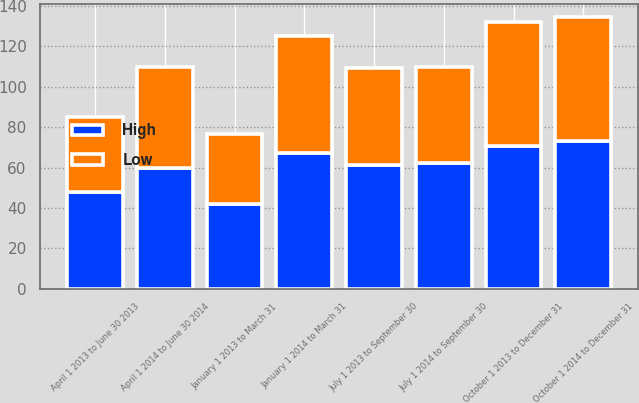<chart> <loc_0><loc_0><loc_500><loc_500><stacked_bar_chart><ecel><fcel>January 1 2014 to March 31<fcel>April 1 2014 to June 30 2014<fcel>July 1 2014 to September 30<fcel>October 1 2014 to December 31<fcel>January 1 2013 to March 31<fcel>April 1 2013 to June 30 2013<fcel>July 1 2013 to September 30<fcel>October 1 2013 to December 31<nl><fcel>High<fcel>67.16<fcel>59.65<fcel>62.05<fcel>73.25<fcel>41.85<fcel>47.8<fcel>61.47<fcel>70.6<nl><fcel>Low<fcel>57.99<fcel>50.3<fcel>47.5<fcel>61.15<fcel>34.79<fcel>37.09<fcel>47.59<fcel>61.34<nl></chart> 